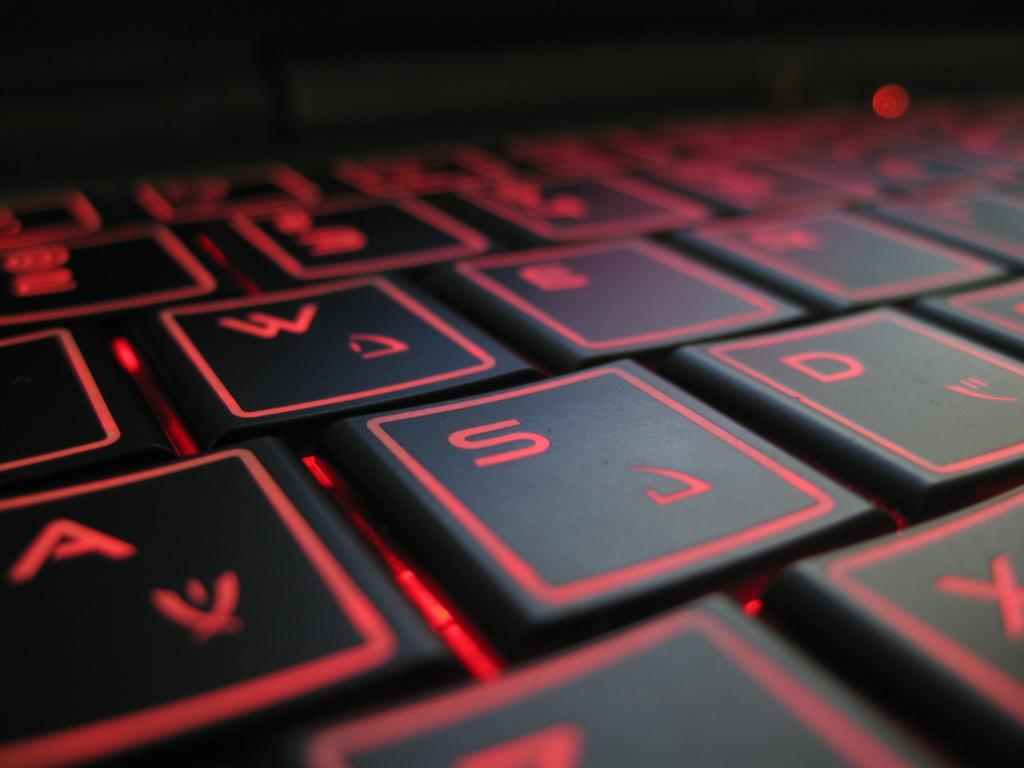<image>
Present a compact description of the photo's key features. A black laptop keyboard where visible keys include A, S, D, and W. 